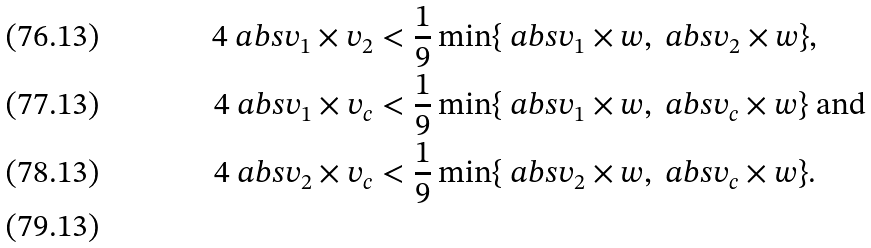<formula> <loc_0><loc_0><loc_500><loc_500>4 \ a b s { v _ { 1 } \times v _ { 2 } } & < \frac { 1 } { 9 } \min \{ \ a b s { v _ { 1 } \times w } , \ a b s { v _ { 2 } \times w } \} , \\ 4 \ a b s { v _ { 1 } \times v _ { c } } & < \frac { 1 } { 9 } \min \{ \ a b s { v _ { 1 } \times w } , \ a b s { v _ { c } \times w } \} \text { and} \\ 4 \ a b s { v _ { 2 } \times v _ { c } } & < \frac { 1 } { 9 } \min \{ \ a b s { v _ { 2 } \times w } , \ a b s { v _ { c } \times w } \} . \\</formula> 